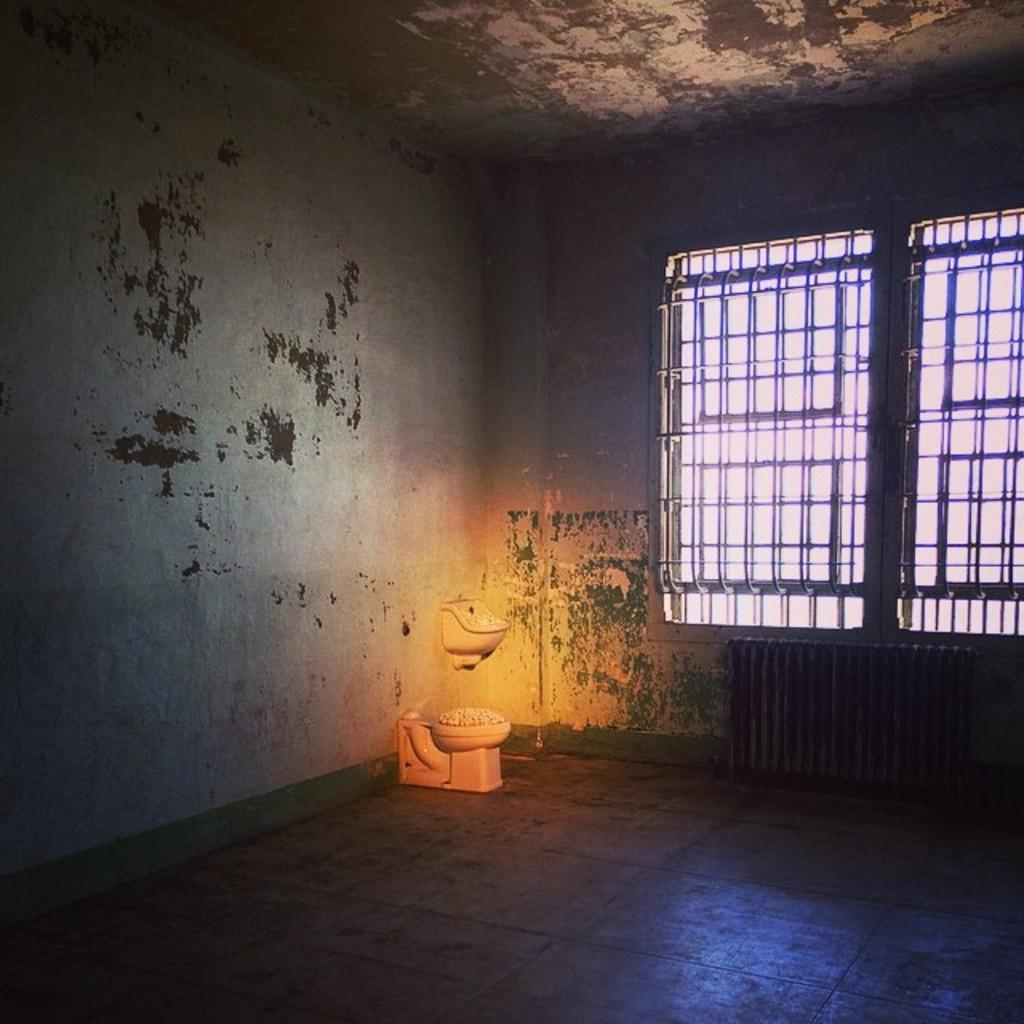What type of space is shown in the image? The image is an inside view of a room. Where is the window located in the room? The window is on the right side of the wall. What is the purpose of the object placed on the floor? There is a toilet placed on the floor. What is the main feature on the left side of the room? There is a wall on the left side of the room. How many balls can be seen bouncing around in the room? There are no balls visible in the image; it shows an inside view of a room with a window, a toilet, and a wall. 